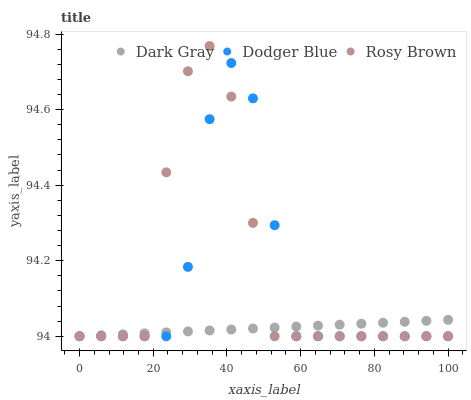Does Dark Gray have the minimum area under the curve?
Answer yes or no. Yes. Does Rosy Brown have the maximum area under the curve?
Answer yes or no. Yes. Does Dodger Blue have the minimum area under the curve?
Answer yes or no. No. Does Dodger Blue have the maximum area under the curve?
Answer yes or no. No. Is Dark Gray the smoothest?
Answer yes or no. Yes. Is Rosy Brown the roughest?
Answer yes or no. Yes. Is Dodger Blue the smoothest?
Answer yes or no. No. Is Dodger Blue the roughest?
Answer yes or no. No. Does Dark Gray have the lowest value?
Answer yes or no. Yes. Does Rosy Brown have the highest value?
Answer yes or no. Yes. Does Dodger Blue have the highest value?
Answer yes or no. No. Does Rosy Brown intersect Dark Gray?
Answer yes or no. Yes. Is Rosy Brown less than Dark Gray?
Answer yes or no. No. Is Rosy Brown greater than Dark Gray?
Answer yes or no. No. 